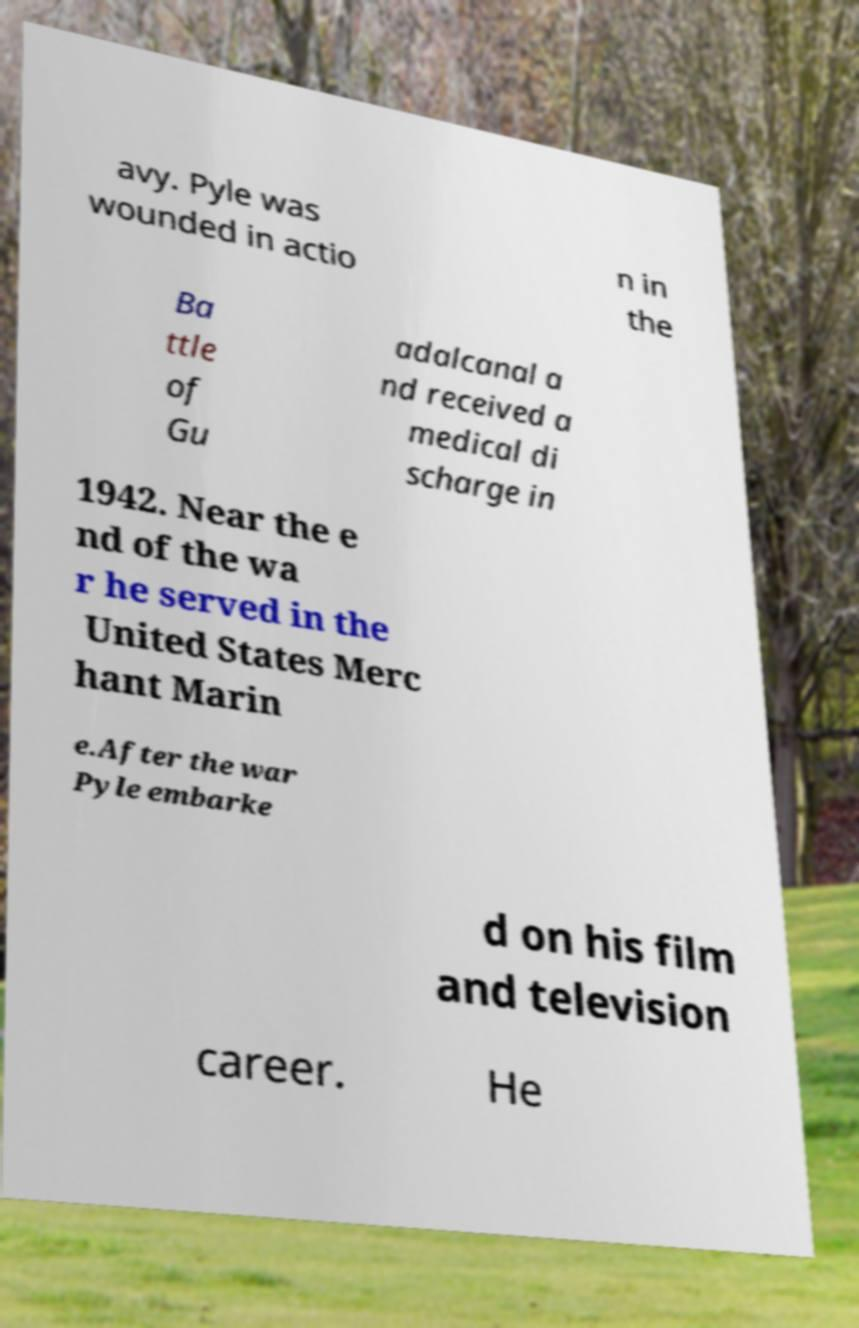Can you accurately transcribe the text from the provided image for me? avy. Pyle was wounded in actio n in the Ba ttle of Gu adalcanal a nd received a medical di scharge in 1942. Near the e nd of the wa r he served in the United States Merc hant Marin e.After the war Pyle embarke d on his film and television career. He 